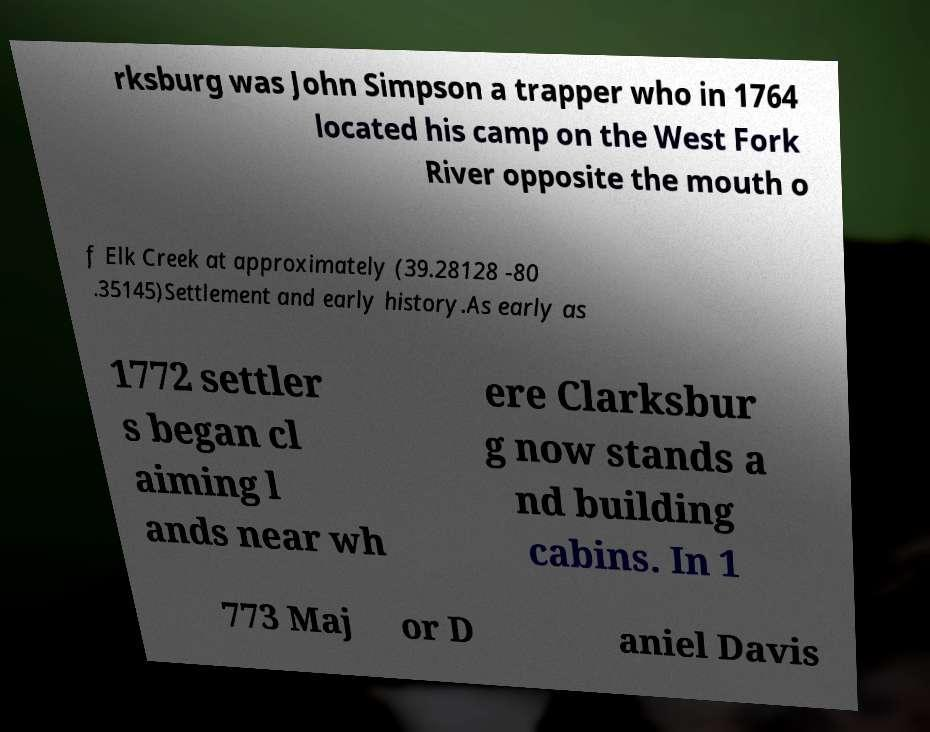What messages or text are displayed in this image? I need them in a readable, typed format. rksburg was John Simpson a trapper who in 1764 located his camp on the West Fork River opposite the mouth o f Elk Creek at approximately (39.28128 -80 .35145)Settlement and early history.As early as 1772 settler s began cl aiming l ands near wh ere Clarksbur g now stands a nd building cabins. In 1 773 Maj or D aniel Davis 